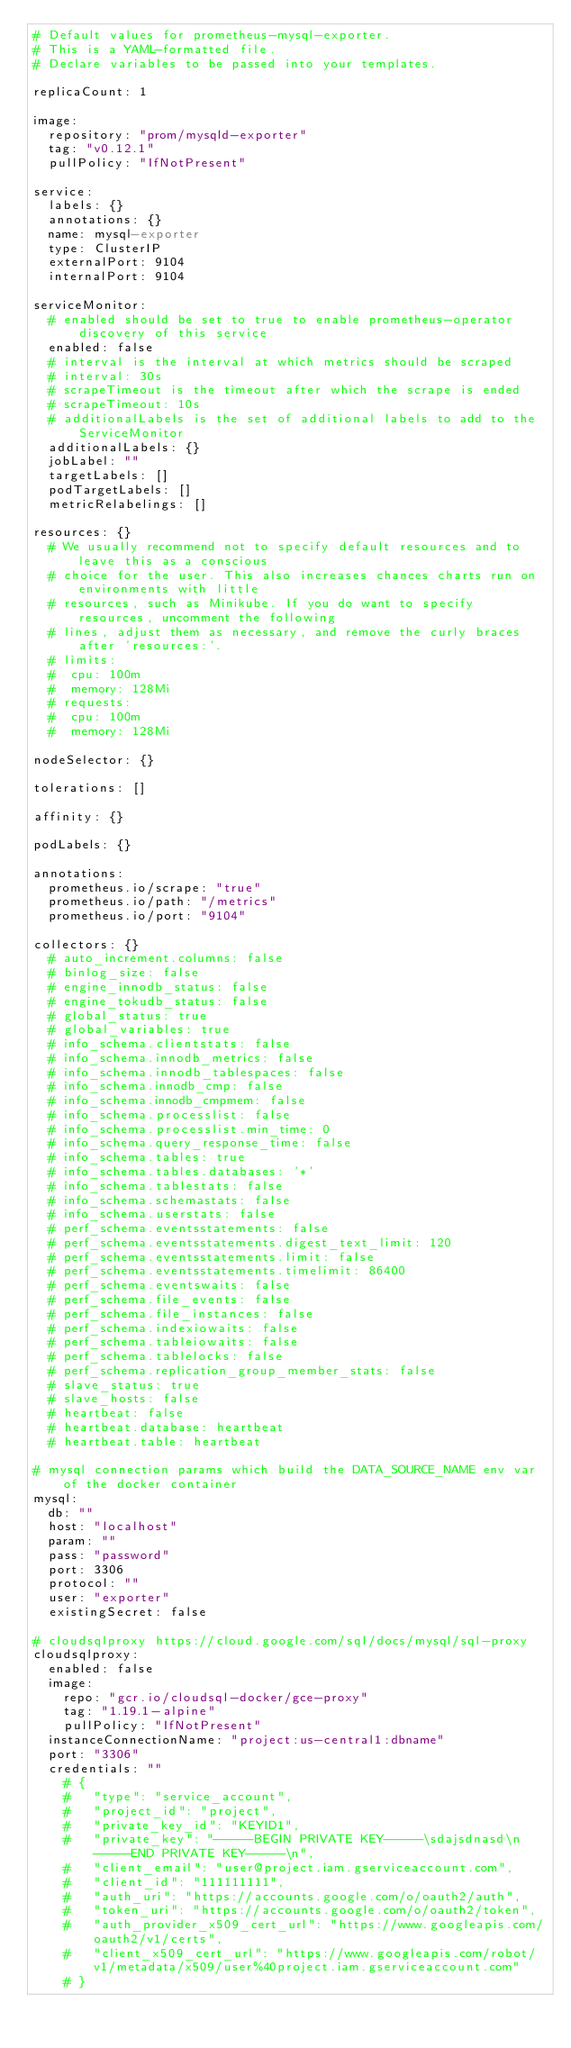Convert code to text. <code><loc_0><loc_0><loc_500><loc_500><_YAML_># Default values for prometheus-mysql-exporter.
# This is a YAML-formatted file.
# Declare variables to be passed into your templates.

replicaCount: 1

image:
  repository: "prom/mysqld-exporter"
  tag: "v0.12.1"
  pullPolicy: "IfNotPresent"

service:
  labels: {}
  annotations: {}
  name: mysql-exporter
  type: ClusterIP
  externalPort: 9104
  internalPort: 9104

serviceMonitor:
  # enabled should be set to true to enable prometheus-operator discovery of this service
  enabled: false
  # interval is the interval at which metrics should be scraped
  # interval: 30s
  # scrapeTimeout is the timeout after which the scrape is ended
  # scrapeTimeout: 10s
  # additionalLabels is the set of additional labels to add to the ServiceMonitor
  additionalLabels: {}
  jobLabel: ""
  targetLabels: []
  podTargetLabels: []
  metricRelabelings: []

resources: {}
  # We usually recommend not to specify default resources and to leave this as a conscious
  # choice for the user. This also increases chances charts run on environments with little
  # resources, such as Minikube. If you do want to specify resources, uncomment the following
  # lines, adjust them as necessary, and remove the curly braces after 'resources:'.
  # limits:
  #  cpu: 100m
  #  memory: 128Mi
  # requests:
  #  cpu: 100m
  #  memory: 128Mi

nodeSelector: {}

tolerations: []

affinity: {}

podLabels: {}

annotations:
  prometheus.io/scrape: "true"
  prometheus.io/path: "/metrics"
  prometheus.io/port: "9104"

collectors: {}
  # auto_increment.columns: false
  # binlog_size: false
  # engine_innodb_status: false
  # engine_tokudb_status: false
  # global_status: true
  # global_variables: true
  # info_schema.clientstats: false
  # info_schema.innodb_metrics: false
  # info_schema.innodb_tablespaces: false
  # info_schema.innodb_cmp: false
  # info_schema.innodb_cmpmem: false
  # info_schema.processlist: false
  # info_schema.processlist.min_time: 0
  # info_schema.query_response_time: false
  # info_schema.tables: true
  # info_schema.tables.databases: '*'
  # info_schema.tablestats: false
  # info_schema.schemastats: false
  # info_schema.userstats: false
  # perf_schema.eventsstatements: false
  # perf_schema.eventsstatements.digest_text_limit: 120
  # perf_schema.eventsstatements.limit: false
  # perf_schema.eventsstatements.timelimit: 86400
  # perf_schema.eventswaits: false
  # perf_schema.file_events: false
  # perf_schema.file_instances: false
  # perf_schema.indexiowaits: false
  # perf_schema.tableiowaits: false
  # perf_schema.tablelocks: false
  # perf_schema.replication_group_member_stats: false
  # slave_status: true
  # slave_hosts: false
  # heartbeat: false
  # heartbeat.database: heartbeat
  # heartbeat.table: heartbeat

# mysql connection params which build the DATA_SOURCE_NAME env var of the docker container
mysql:
  db: ""
  host: "localhost"
  param: ""
  pass: "password"
  port: 3306
  protocol: ""
  user: "exporter"
  existingSecret: false

# cloudsqlproxy https://cloud.google.com/sql/docs/mysql/sql-proxy
cloudsqlproxy:
  enabled: false
  image:
    repo: "gcr.io/cloudsql-docker/gce-proxy"
    tag: "1.19.1-alpine"
    pullPolicy: "IfNotPresent"
  instanceConnectionName: "project:us-central1:dbname"
  port: "3306"
  credentials: ""
    # {
    #   "type": "service_account",
    #   "project_id": "project",
    #   "private_key_id": "KEYID1",
    #   "private_key": "-----BEGIN PRIVATE KEY-----\sdajsdnasd\n-----END PRIVATE KEY-----\n",
    #   "client_email": "user@project.iam.gserviceaccount.com",
    #   "client_id": "111111111",
    #   "auth_uri": "https://accounts.google.com/o/oauth2/auth",
    #   "token_uri": "https://accounts.google.com/o/oauth2/token",
    #   "auth_provider_x509_cert_url": "https://www.googleapis.com/oauth2/v1/certs",
    #   "client_x509_cert_url": "https://www.googleapis.com/robot/v1/metadata/x509/user%40project.iam.gserviceaccount.com"
    # }
</code> 